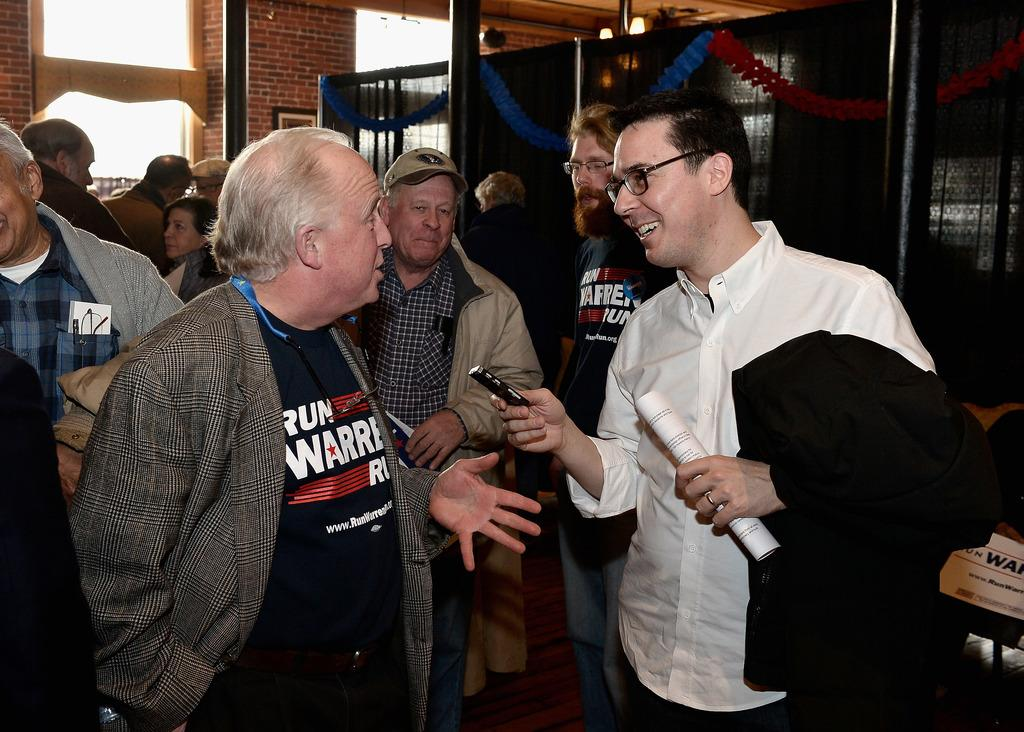What is happening in the foreground of the image? There is a group of people in the foreground of the image. What is the position of the people in the image? The people are on the floor. What else can be seen in the foreground of the image? There are objects in the foreground. What is visible in the background of the image? There is a wall, windows, and metal objects in the background. What type of location might the image be taken in? The image is likely taken in a hall. What type of bike is the daughter riding in the image? There is no bike or daughter present in the image. What rule is being enforced in the image? There is no rule being enforced in the image; it simply shows a group of people on the floor with objects in the foreground and a wall, windows, and metal objects in the background. 